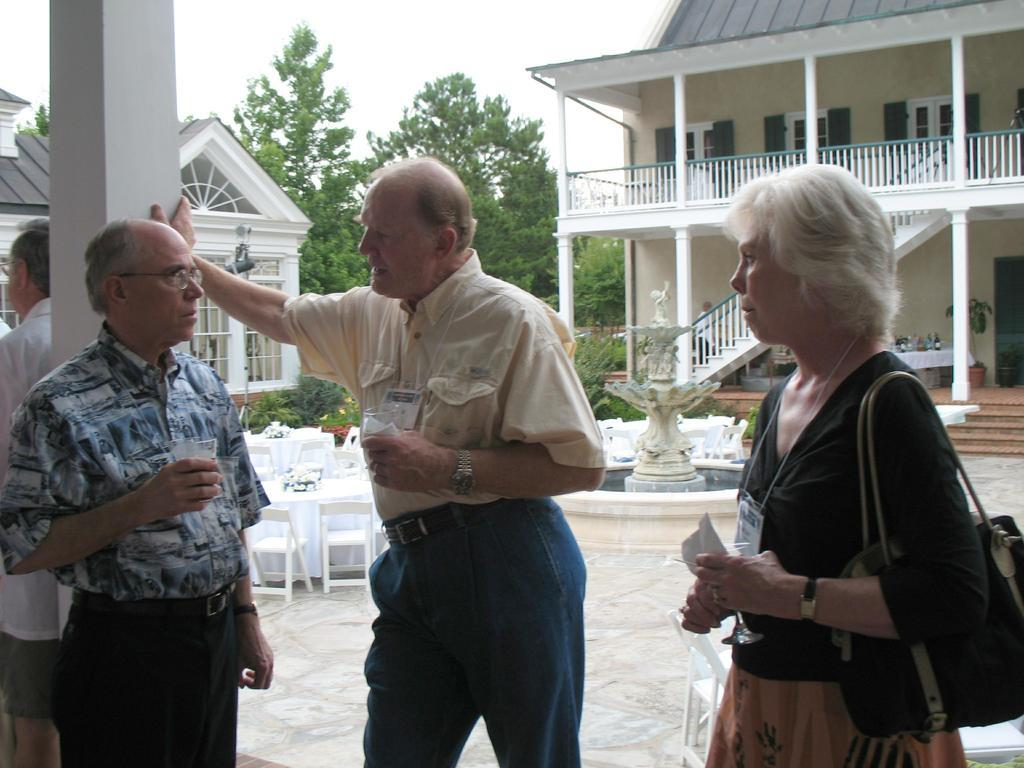What can be seen in the image? There are people standing in the image, along with a fountain, chairs, and tables. What is in the background of the image? In the background of the image, there are houses, trees, and the sky. Can you describe the setting of the image? The image appears to be set in an outdoor area with a fountain, seating, and a view of houses and trees in the distance. What type of fog can be seen in the image? There is no fog present in the image; the sky is visible. Is there a jail visible in the image? There is no jail present in the image. 